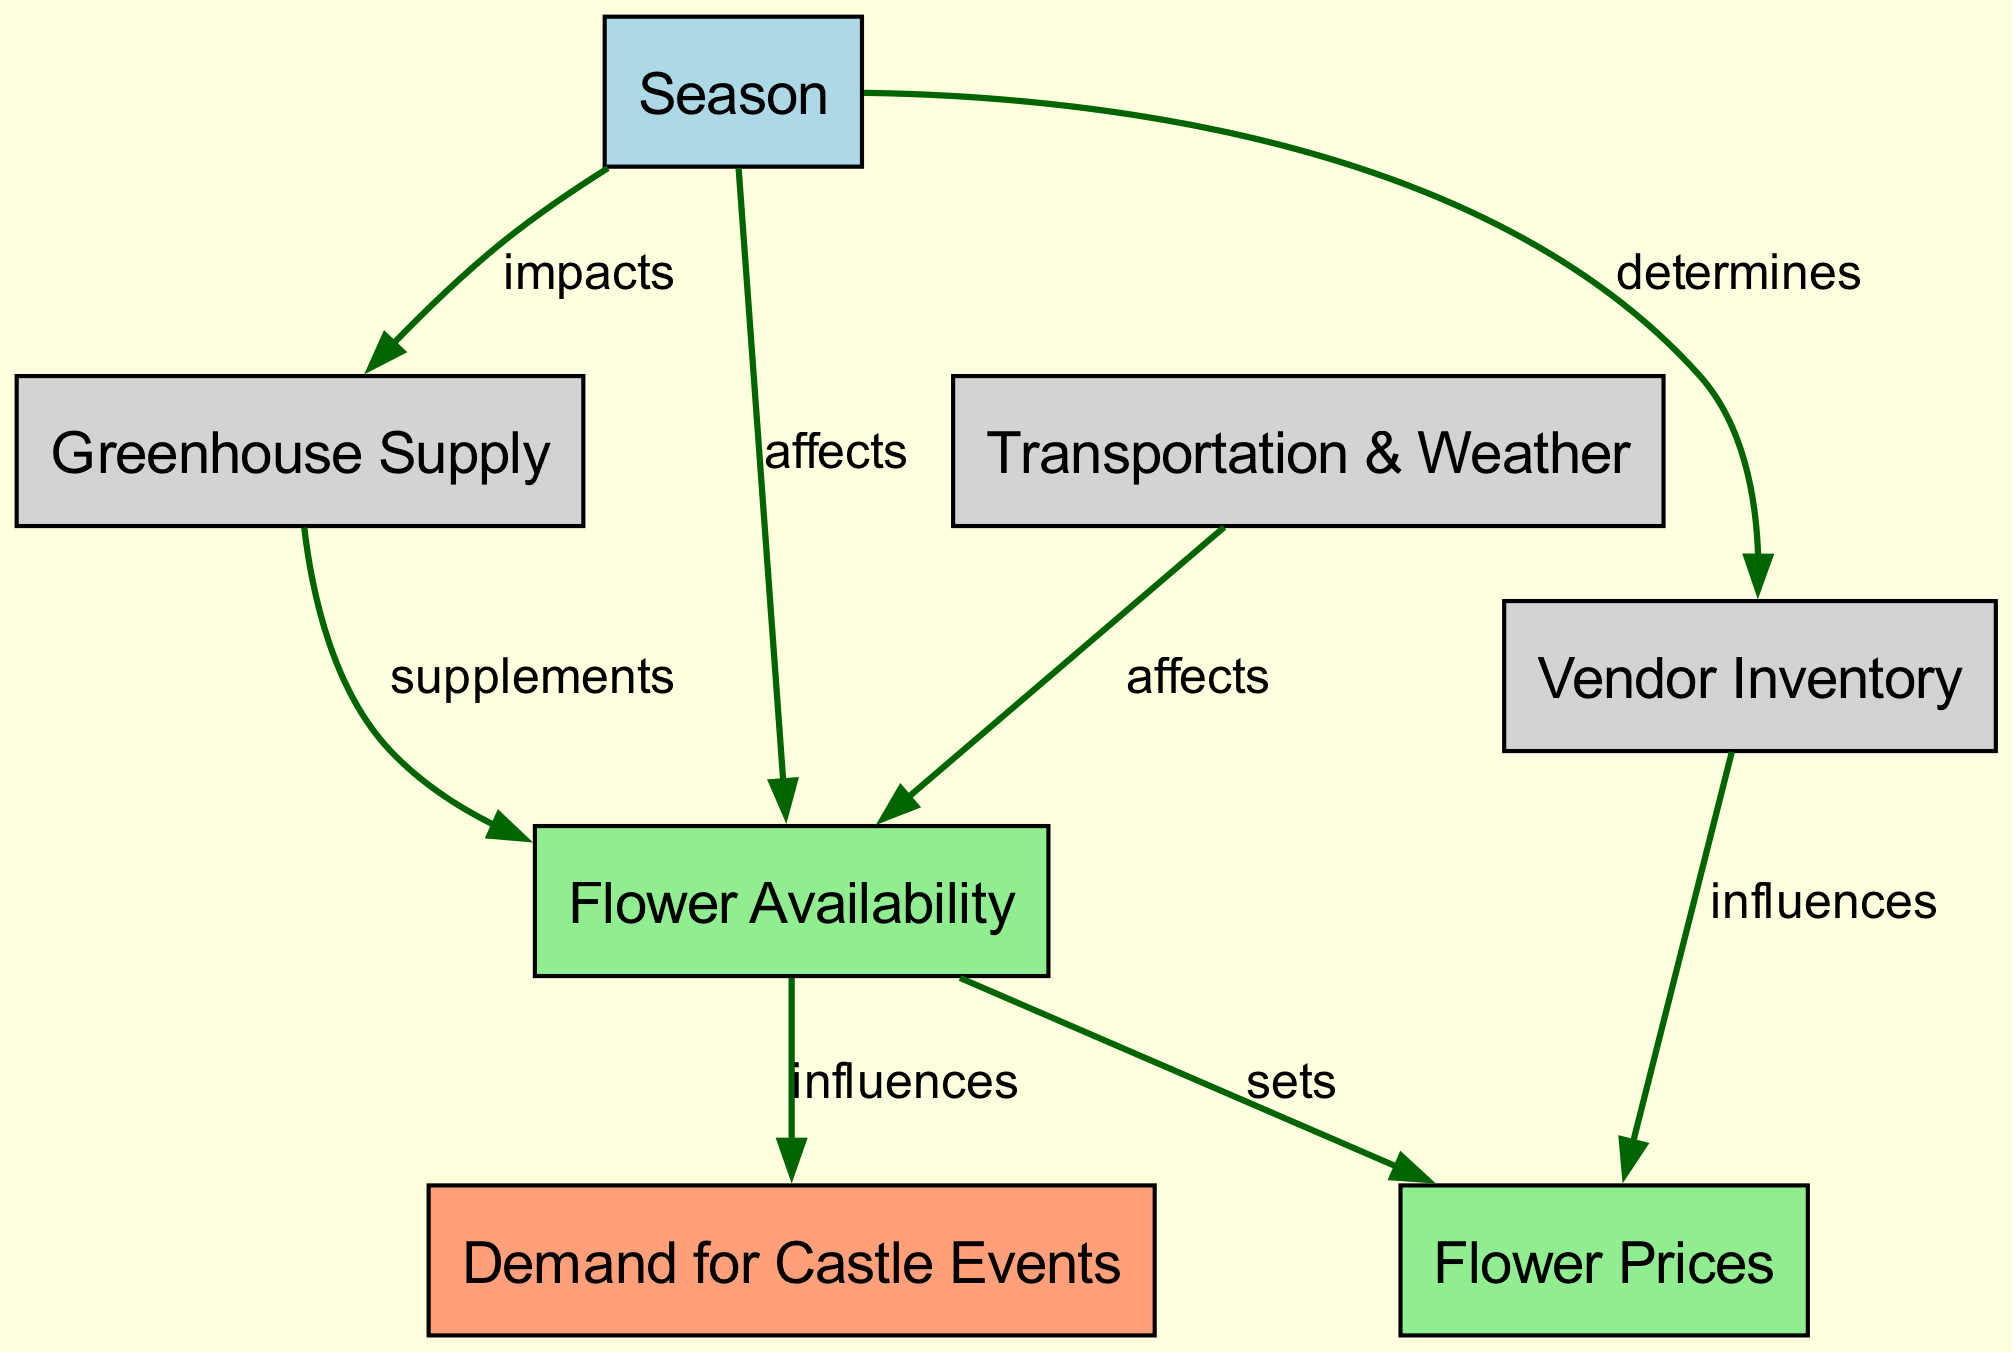What are the nodes in the diagram? The nodes mentioned in the diagram are: Season, Flower Availability, Demand for Castle Events, Greenhouse Supply, Transportation & Weather, Vendor Inventory, Flower Prices.
Answer: Season, Flower Availability, Demand for Castle Events, Greenhouse Supply, Transportation & Weather, Vendor Inventory, Flower Prices How many edges are in the diagram? There are 8 edges in the diagram, each representing a relationship between different nodes as indicated in the edge list.
Answer: 8 What node does "Season" affect? The diagram shows that "Season" affects "Flower Availability" and "Supply Greenhouses," directly influencing these nodes in the food chain.
Answer: Flower Availability, Supply Greenhouses Which node influences "Flower Prices"? The "Flower Availability" node sets the "Flower Prices," as indicated by the connection made between these two nodes.
Answer: Flower Availability What is determined by "Season"? According to the diagram, "Season" determines "Vendor Inventory," indicating its role in shaping the stock available for vendors.
Answer: Vendor Inventory Which two nodes are connected by the edge labeled "supplements"? The edge labeled "supplements" connects "Supply Greenhouses" to "Flower Availability," showing how greenhouse supply contributes to flower availability.
Answer: Supply Greenhouses, Flower Availability If "Flower Availability" decreases, what is the expected impact on "Demand for Castle Events"? "Flower Availability" influences "Demand for Castle Events"; thus, if flower availability decreases, demand may not be met, likely impacting the events negatively.
Answer: Decrease What relationship does "Transportation & Weather" have with "Flower Availability"? The diagram indicates that "Transportation & Weather" affects "Flower Availability," meaning that weather conditions and transportation logistics impact the availability of flowers.
Answer: Affects Which node is influenced by both "Vendor Inventory" and "Flower Availability"? "Flower Prices" are influenced by both "Vendor Inventory" and "Flower Availability," as represented in the edges leading to this node in the diagram.
Answer: Flower Prices 